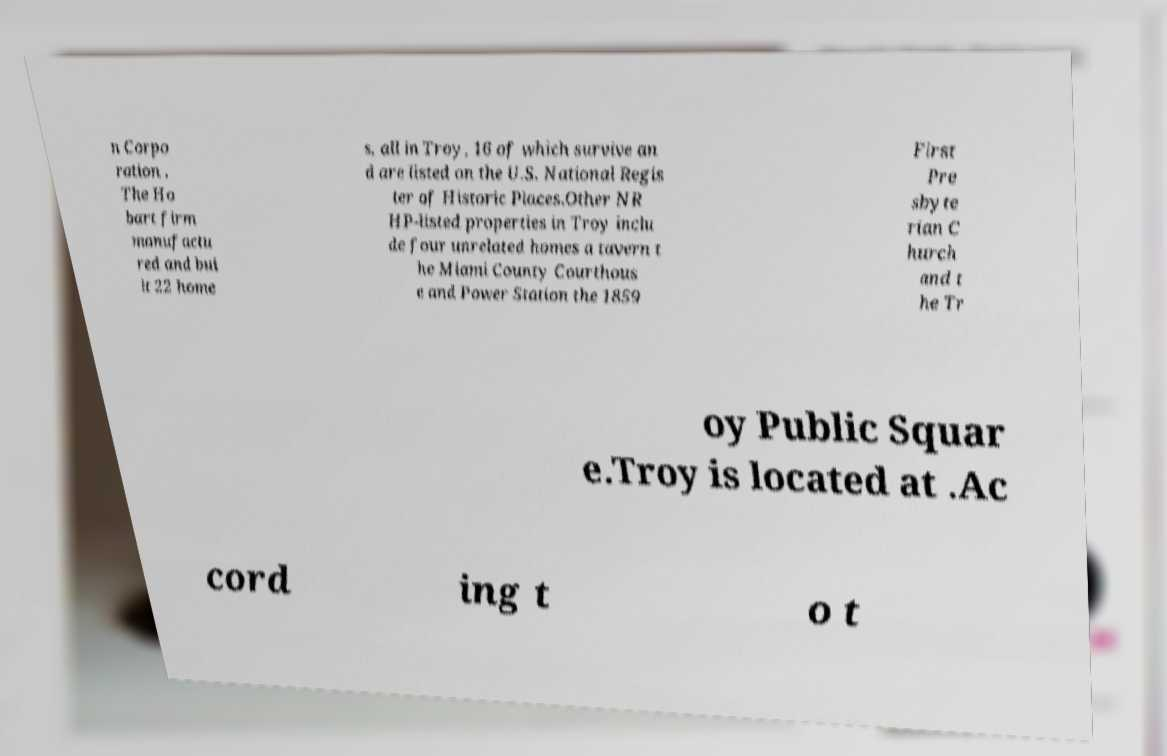Please identify and transcribe the text found in this image. n Corpo ration . The Ho bart firm manufactu red and bui lt 22 home s, all in Troy, 16 of which survive an d are listed on the U.S. National Regis ter of Historic Places.Other NR HP-listed properties in Troy inclu de four unrelated homes a tavern t he Miami County Courthous e and Power Station the 1859 First Pre sbyte rian C hurch and t he Tr oy Public Squar e.Troy is located at .Ac cord ing t o t 